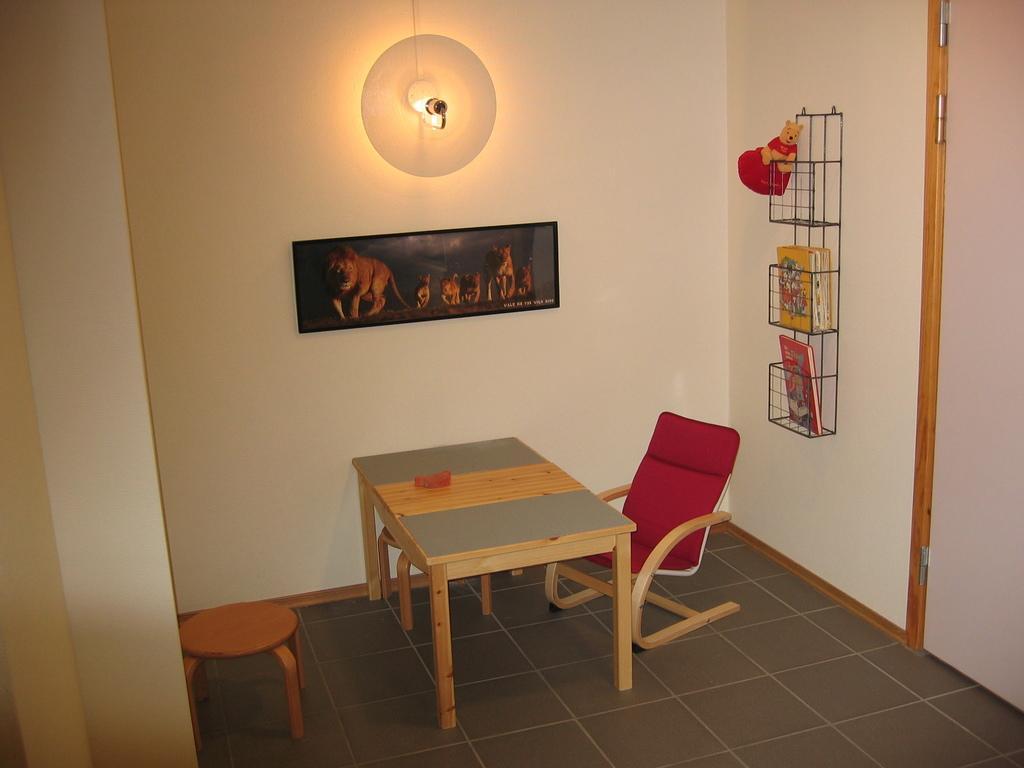In one or two sentences, can you explain what this image depicts? In this picture we can observe a table in this room. There is a stool and a red color chair. We can observe a shelf fixed to the wall in the right side. There is a door. We can observe photo frame attached to the wall and a light here. 